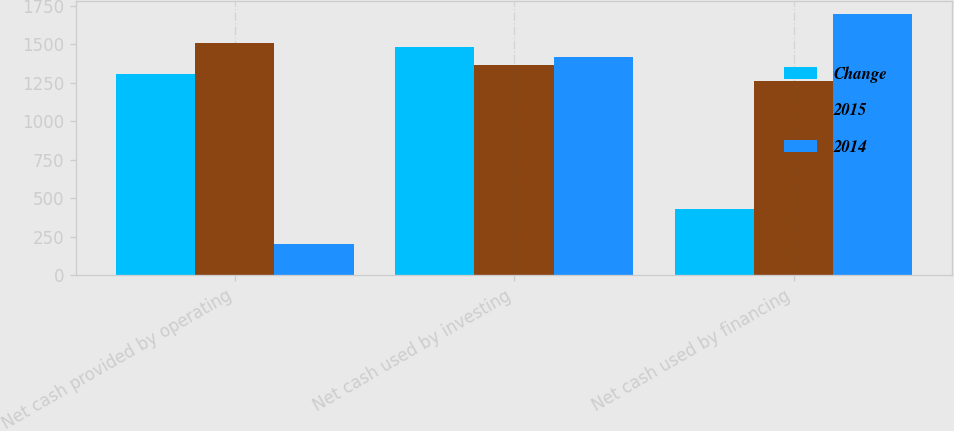Convert chart. <chart><loc_0><loc_0><loc_500><loc_500><stacked_bar_chart><ecel><fcel>Net cash provided by operating<fcel>Net cash used by investing<fcel>Net cash used by financing<nl><fcel>Change<fcel>1309<fcel>1485<fcel>432<nl><fcel>2015<fcel>1510<fcel>1363.5<fcel>1265<nl><fcel>2014<fcel>201<fcel>1418<fcel>1697<nl></chart> 